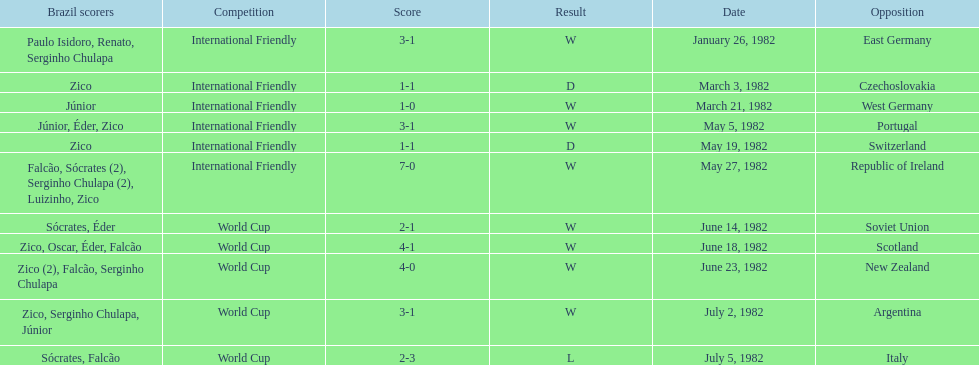In the 1982 season, how many matches were played between brazil and west germany? 1. 